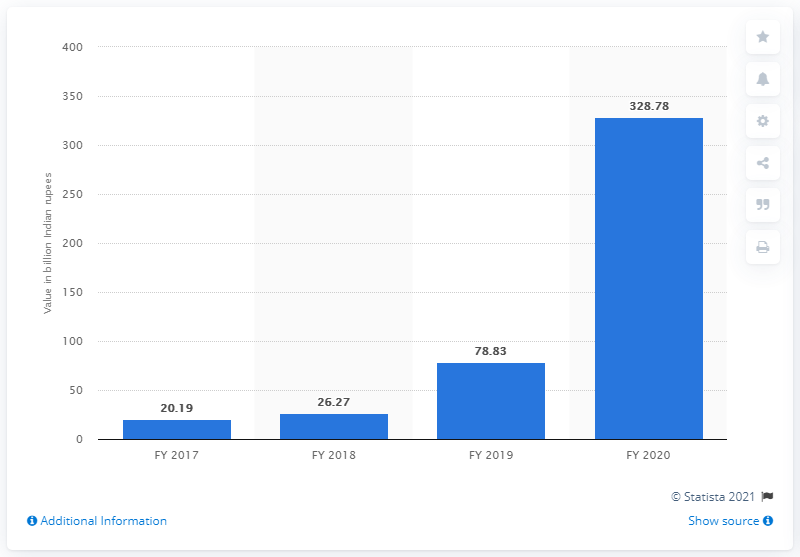Specify some key components in this picture. In the fiscal year 2020, the gross non-performing assets (GNPA) of YES bank were valued at 328.78 Indian rupees. 